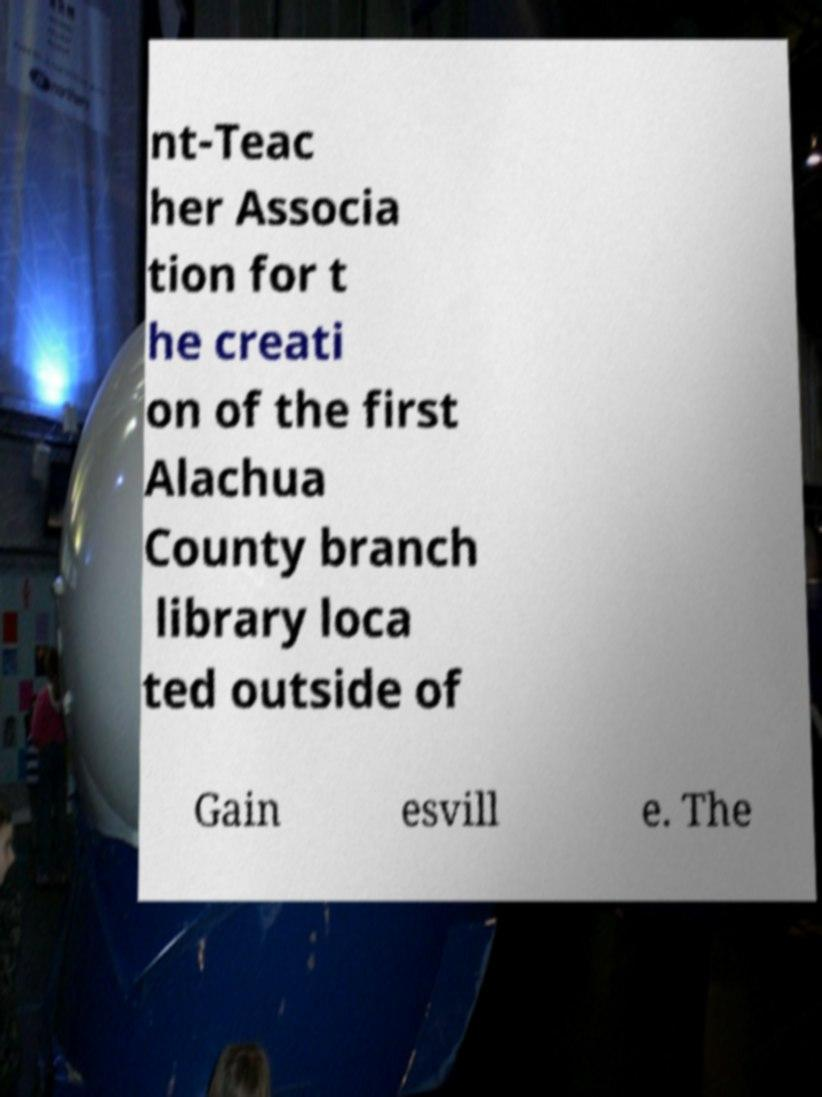There's text embedded in this image that I need extracted. Can you transcribe it verbatim? nt-Teac her Associa tion for t he creati on of the first Alachua County branch library loca ted outside of Gain esvill e. The 